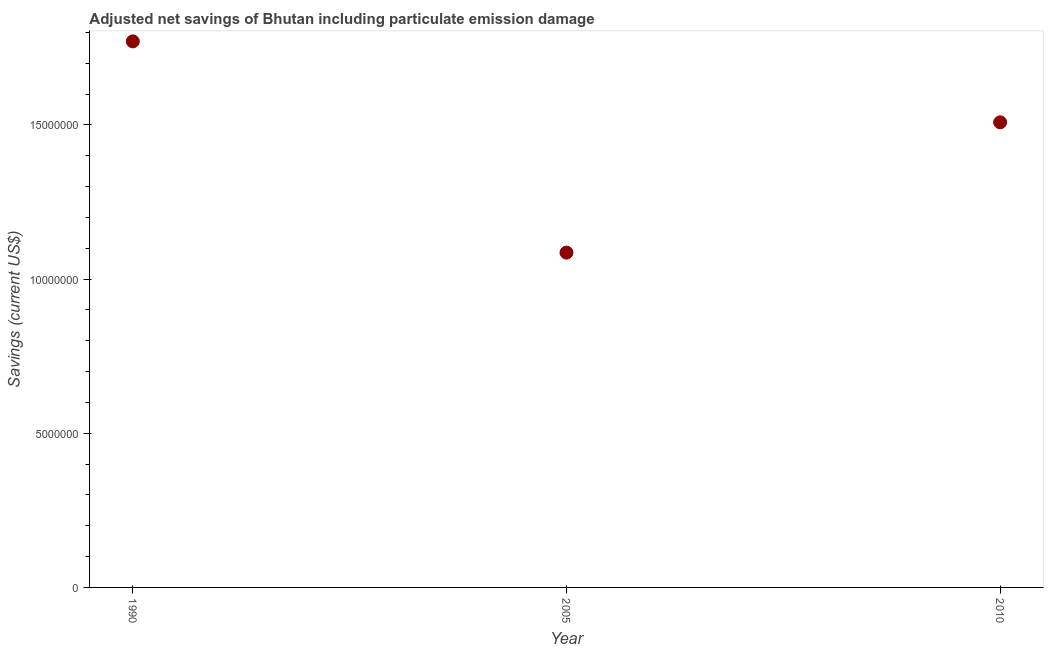What is the adjusted net savings in 2010?
Keep it short and to the point. 1.51e+07. Across all years, what is the maximum adjusted net savings?
Give a very brief answer. 1.77e+07. Across all years, what is the minimum adjusted net savings?
Keep it short and to the point. 1.09e+07. In which year was the adjusted net savings maximum?
Give a very brief answer. 1990. What is the sum of the adjusted net savings?
Ensure brevity in your answer.  4.36e+07. What is the difference between the adjusted net savings in 2005 and 2010?
Provide a succinct answer. -4.23e+06. What is the average adjusted net savings per year?
Offer a terse response. 1.45e+07. What is the median adjusted net savings?
Offer a very short reply. 1.51e+07. In how many years, is the adjusted net savings greater than 6000000 US$?
Give a very brief answer. 3. What is the ratio of the adjusted net savings in 2005 to that in 2010?
Give a very brief answer. 0.72. What is the difference between the highest and the second highest adjusted net savings?
Provide a short and direct response. 2.62e+06. Is the sum of the adjusted net savings in 1990 and 2005 greater than the maximum adjusted net savings across all years?
Provide a succinct answer. Yes. What is the difference between the highest and the lowest adjusted net savings?
Your response must be concise. 6.85e+06. How many years are there in the graph?
Give a very brief answer. 3. Does the graph contain grids?
Your response must be concise. No. What is the title of the graph?
Your answer should be very brief. Adjusted net savings of Bhutan including particulate emission damage. What is the label or title of the Y-axis?
Make the answer very short. Savings (current US$). What is the Savings (current US$) in 1990?
Give a very brief answer. 1.77e+07. What is the Savings (current US$) in 2005?
Your answer should be compact. 1.09e+07. What is the Savings (current US$) in 2010?
Offer a very short reply. 1.51e+07. What is the difference between the Savings (current US$) in 1990 and 2005?
Ensure brevity in your answer.  6.85e+06. What is the difference between the Savings (current US$) in 1990 and 2010?
Ensure brevity in your answer.  2.62e+06. What is the difference between the Savings (current US$) in 2005 and 2010?
Ensure brevity in your answer.  -4.23e+06. What is the ratio of the Savings (current US$) in 1990 to that in 2005?
Make the answer very short. 1.63. What is the ratio of the Savings (current US$) in 1990 to that in 2010?
Provide a succinct answer. 1.17. What is the ratio of the Savings (current US$) in 2005 to that in 2010?
Make the answer very short. 0.72. 